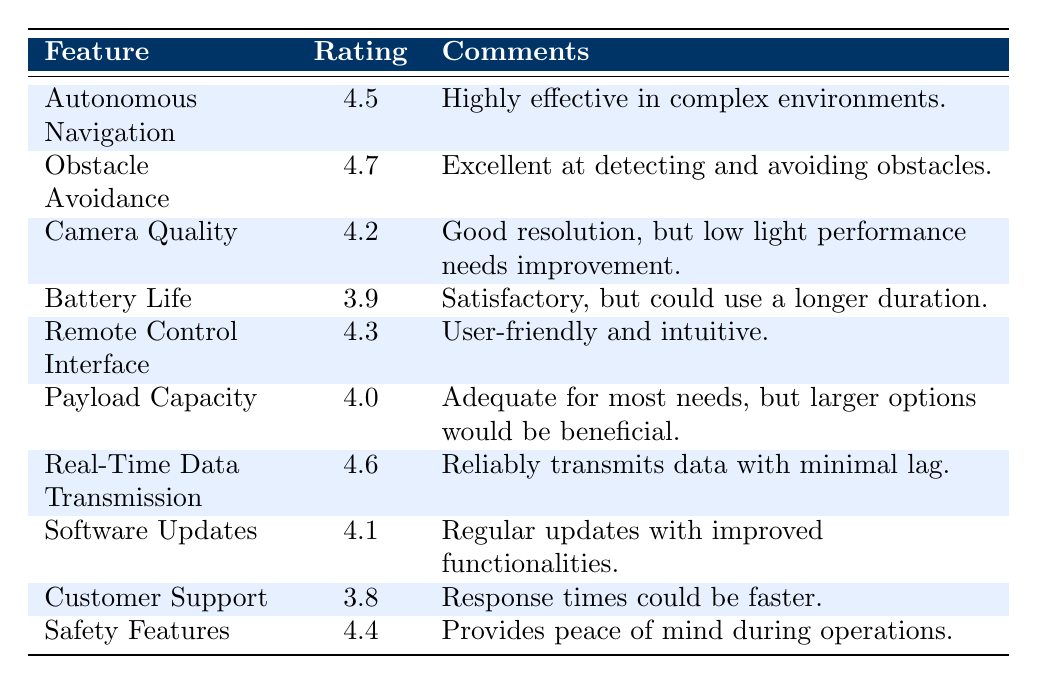What is the satisfaction rating for Obstacle Avoidance? The table lists the satisfaction rating for Obstacle Avoidance as 4.7.
Answer: 4.7 What feature has the highest satisfaction rating? By comparing the satisfaction ratings in the table, Obstacle Avoidance has the highest rating at 4.7.
Answer: Obstacle Avoidance What is the satisfaction rating for Camera Quality? The table shows that Camera Quality has a satisfaction rating of 4.2.
Answer: 4.2 What is the average satisfaction rating for the features listed? To calculate the average, sum the ratings: (4.5 + 4.7 + 4.2 + 3.9 + 4.3 + 4.0 + 4.6 + 4.1 + 3.8 + 4.4) = 43.6. There are 10 features, so the average rating is 43.6 / 10 = 4.36.
Answer: 4.36 Is there a feature with a satisfaction rating lower than 4? Yes, Customer Support has a rating of 3.8, which is below 4.
Answer: Yes Which feature has the lowest satisfaction rating? By reviewing the ratings, Customer Support has the lowest rating at 3.8.
Answer: Customer Support Is Battery Life rated higher than Payload Capacity? Battery Life has a rating of 3.9, while Payload Capacity is rated at 4.0. Therefore, Battery Life is not rated higher than Payload Capacity.
Answer: No What is the difference in satisfaction ratings between Real-Time Data Transmission and Battery Life? Real-Time Data Transmission has a rating of 4.6, while Battery Life has a rating of 3.9. The difference is 4.6 - 3.9 = 0.7.
Answer: 0.7 Which feature received comments about needing improvement, and what was the comment? The feature Camera Quality received comments about needing improvement, specifically noting that “low light performance needs improvement.”
Answer: Camera Quality: low light performance needs improvement What percentage of features have a satisfaction rating of 4.0 or higher? There are 8 features rated 4.0 or higher out of 10 total features. Therefore, the percentage is (8/10) * 100 = 80%.
Answer: 80% 